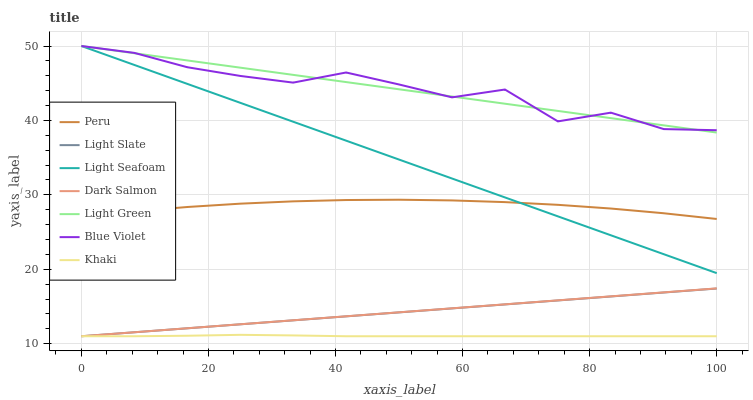Does Khaki have the minimum area under the curve?
Answer yes or no. Yes. Does Light Green have the maximum area under the curve?
Answer yes or no. Yes. Does Peru have the minimum area under the curve?
Answer yes or no. No. Does Peru have the maximum area under the curve?
Answer yes or no. No. Is Dark Salmon the smoothest?
Answer yes or no. Yes. Is Blue Violet the roughest?
Answer yes or no. Yes. Is Peru the smoothest?
Answer yes or no. No. Is Peru the roughest?
Answer yes or no. No. Does Khaki have the lowest value?
Answer yes or no. Yes. Does Peru have the lowest value?
Answer yes or no. No. Does Blue Violet have the highest value?
Answer yes or no. Yes. Does Peru have the highest value?
Answer yes or no. No. Is Light Slate less than Peru?
Answer yes or no. Yes. Is Light Green greater than Dark Salmon?
Answer yes or no. Yes. Does Light Green intersect Blue Violet?
Answer yes or no. Yes. Is Light Green less than Blue Violet?
Answer yes or no. No. Is Light Green greater than Blue Violet?
Answer yes or no. No. Does Light Slate intersect Peru?
Answer yes or no. No. 